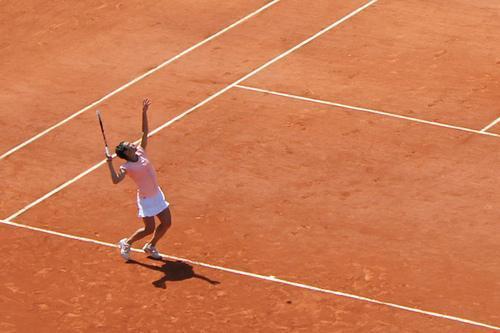How many tennis players are wearing a red skirt?
Give a very brief answer. 0. 